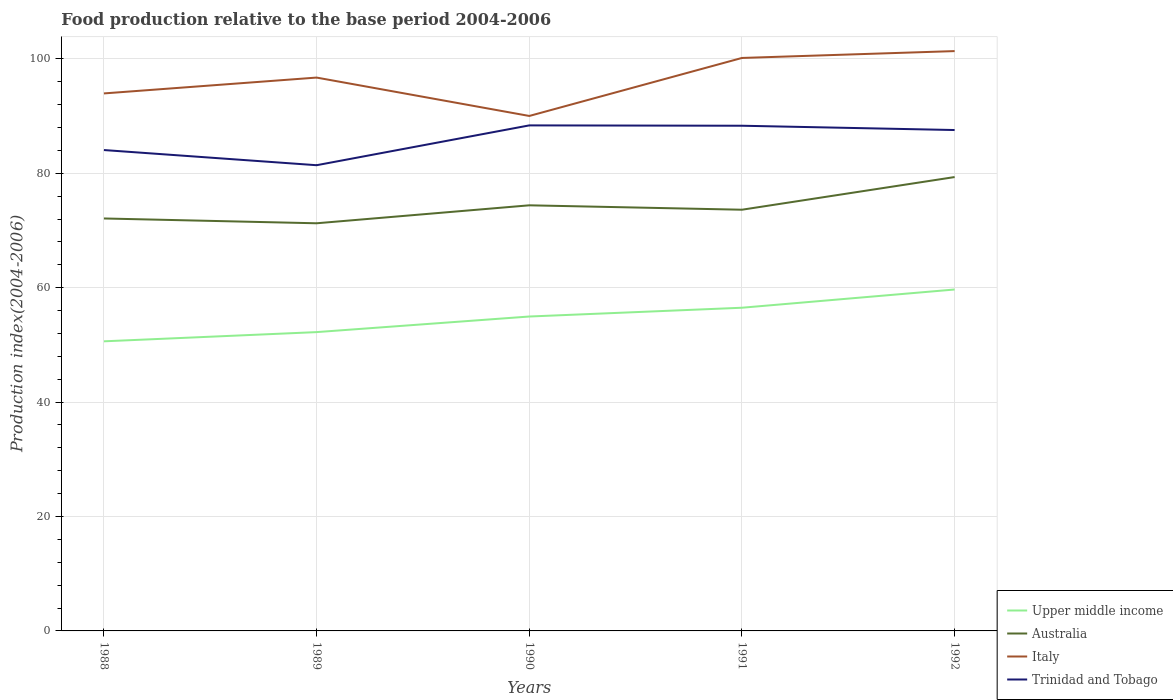How many different coloured lines are there?
Make the answer very short. 4. Does the line corresponding to Trinidad and Tobago intersect with the line corresponding to Italy?
Your answer should be compact. No. Is the number of lines equal to the number of legend labels?
Keep it short and to the point. Yes. Across all years, what is the maximum food production index in Australia?
Your response must be concise. 71.26. What is the total food production index in Trinidad and Tobago in the graph?
Keep it short and to the point. -6.15. What is the difference between the highest and the second highest food production index in Trinidad and Tobago?
Keep it short and to the point. 6.96. What is the difference between the highest and the lowest food production index in Trinidad and Tobago?
Offer a very short reply. 3. Is the food production index in Italy strictly greater than the food production index in Australia over the years?
Ensure brevity in your answer.  No. How many years are there in the graph?
Provide a succinct answer. 5. Are the values on the major ticks of Y-axis written in scientific E-notation?
Your response must be concise. No. Does the graph contain grids?
Offer a very short reply. Yes. How many legend labels are there?
Provide a succinct answer. 4. What is the title of the graph?
Your answer should be very brief. Food production relative to the base period 2004-2006. What is the label or title of the X-axis?
Your answer should be compact. Years. What is the label or title of the Y-axis?
Keep it short and to the point. Production index(2004-2006). What is the Production index(2004-2006) of Upper middle income in 1988?
Keep it short and to the point. 50.62. What is the Production index(2004-2006) in Australia in 1988?
Make the answer very short. 72.1. What is the Production index(2004-2006) in Italy in 1988?
Make the answer very short. 93.96. What is the Production index(2004-2006) of Trinidad and Tobago in 1988?
Your answer should be compact. 84.06. What is the Production index(2004-2006) in Upper middle income in 1989?
Give a very brief answer. 52.24. What is the Production index(2004-2006) of Australia in 1989?
Provide a succinct answer. 71.26. What is the Production index(2004-2006) of Italy in 1989?
Offer a very short reply. 96.73. What is the Production index(2004-2006) of Trinidad and Tobago in 1989?
Your response must be concise. 81.41. What is the Production index(2004-2006) in Upper middle income in 1990?
Ensure brevity in your answer.  54.96. What is the Production index(2004-2006) of Australia in 1990?
Provide a succinct answer. 74.4. What is the Production index(2004-2006) of Italy in 1990?
Provide a succinct answer. 90.02. What is the Production index(2004-2006) of Trinidad and Tobago in 1990?
Give a very brief answer. 88.37. What is the Production index(2004-2006) in Upper middle income in 1991?
Give a very brief answer. 56.5. What is the Production index(2004-2006) of Australia in 1991?
Provide a succinct answer. 73.63. What is the Production index(2004-2006) of Italy in 1991?
Offer a very short reply. 100.16. What is the Production index(2004-2006) in Trinidad and Tobago in 1991?
Keep it short and to the point. 88.31. What is the Production index(2004-2006) in Upper middle income in 1992?
Offer a very short reply. 59.68. What is the Production index(2004-2006) in Australia in 1992?
Ensure brevity in your answer.  79.34. What is the Production index(2004-2006) in Italy in 1992?
Give a very brief answer. 101.36. What is the Production index(2004-2006) in Trinidad and Tobago in 1992?
Provide a short and direct response. 87.56. Across all years, what is the maximum Production index(2004-2006) in Upper middle income?
Provide a short and direct response. 59.68. Across all years, what is the maximum Production index(2004-2006) of Australia?
Ensure brevity in your answer.  79.34. Across all years, what is the maximum Production index(2004-2006) of Italy?
Keep it short and to the point. 101.36. Across all years, what is the maximum Production index(2004-2006) in Trinidad and Tobago?
Offer a terse response. 88.37. Across all years, what is the minimum Production index(2004-2006) in Upper middle income?
Your answer should be compact. 50.62. Across all years, what is the minimum Production index(2004-2006) in Australia?
Give a very brief answer. 71.26. Across all years, what is the minimum Production index(2004-2006) of Italy?
Your answer should be very brief. 90.02. Across all years, what is the minimum Production index(2004-2006) in Trinidad and Tobago?
Offer a very short reply. 81.41. What is the total Production index(2004-2006) in Upper middle income in the graph?
Provide a succinct answer. 274. What is the total Production index(2004-2006) of Australia in the graph?
Make the answer very short. 370.73. What is the total Production index(2004-2006) in Italy in the graph?
Your response must be concise. 482.23. What is the total Production index(2004-2006) of Trinidad and Tobago in the graph?
Your response must be concise. 429.71. What is the difference between the Production index(2004-2006) of Upper middle income in 1988 and that in 1989?
Your answer should be very brief. -1.61. What is the difference between the Production index(2004-2006) of Australia in 1988 and that in 1989?
Provide a succinct answer. 0.84. What is the difference between the Production index(2004-2006) of Italy in 1988 and that in 1989?
Ensure brevity in your answer.  -2.77. What is the difference between the Production index(2004-2006) in Trinidad and Tobago in 1988 and that in 1989?
Your response must be concise. 2.65. What is the difference between the Production index(2004-2006) of Upper middle income in 1988 and that in 1990?
Your response must be concise. -4.34. What is the difference between the Production index(2004-2006) in Australia in 1988 and that in 1990?
Offer a terse response. -2.3. What is the difference between the Production index(2004-2006) in Italy in 1988 and that in 1990?
Give a very brief answer. 3.94. What is the difference between the Production index(2004-2006) in Trinidad and Tobago in 1988 and that in 1990?
Keep it short and to the point. -4.31. What is the difference between the Production index(2004-2006) in Upper middle income in 1988 and that in 1991?
Your response must be concise. -5.87. What is the difference between the Production index(2004-2006) in Australia in 1988 and that in 1991?
Your response must be concise. -1.53. What is the difference between the Production index(2004-2006) in Italy in 1988 and that in 1991?
Keep it short and to the point. -6.2. What is the difference between the Production index(2004-2006) in Trinidad and Tobago in 1988 and that in 1991?
Your answer should be compact. -4.25. What is the difference between the Production index(2004-2006) in Upper middle income in 1988 and that in 1992?
Offer a terse response. -9.06. What is the difference between the Production index(2004-2006) in Australia in 1988 and that in 1992?
Your answer should be very brief. -7.24. What is the difference between the Production index(2004-2006) in Italy in 1988 and that in 1992?
Ensure brevity in your answer.  -7.4. What is the difference between the Production index(2004-2006) in Trinidad and Tobago in 1988 and that in 1992?
Provide a succinct answer. -3.5. What is the difference between the Production index(2004-2006) of Upper middle income in 1989 and that in 1990?
Your answer should be very brief. -2.73. What is the difference between the Production index(2004-2006) of Australia in 1989 and that in 1990?
Your answer should be compact. -3.14. What is the difference between the Production index(2004-2006) of Italy in 1989 and that in 1990?
Provide a succinct answer. 6.71. What is the difference between the Production index(2004-2006) of Trinidad and Tobago in 1989 and that in 1990?
Your answer should be very brief. -6.96. What is the difference between the Production index(2004-2006) in Upper middle income in 1989 and that in 1991?
Give a very brief answer. -4.26. What is the difference between the Production index(2004-2006) of Australia in 1989 and that in 1991?
Offer a terse response. -2.37. What is the difference between the Production index(2004-2006) in Italy in 1989 and that in 1991?
Keep it short and to the point. -3.43. What is the difference between the Production index(2004-2006) of Trinidad and Tobago in 1989 and that in 1991?
Provide a succinct answer. -6.9. What is the difference between the Production index(2004-2006) in Upper middle income in 1989 and that in 1992?
Offer a terse response. -7.45. What is the difference between the Production index(2004-2006) of Australia in 1989 and that in 1992?
Ensure brevity in your answer.  -8.08. What is the difference between the Production index(2004-2006) in Italy in 1989 and that in 1992?
Make the answer very short. -4.63. What is the difference between the Production index(2004-2006) in Trinidad and Tobago in 1989 and that in 1992?
Provide a short and direct response. -6.15. What is the difference between the Production index(2004-2006) in Upper middle income in 1990 and that in 1991?
Make the answer very short. -1.54. What is the difference between the Production index(2004-2006) of Australia in 1990 and that in 1991?
Give a very brief answer. 0.77. What is the difference between the Production index(2004-2006) of Italy in 1990 and that in 1991?
Offer a very short reply. -10.14. What is the difference between the Production index(2004-2006) of Trinidad and Tobago in 1990 and that in 1991?
Keep it short and to the point. 0.06. What is the difference between the Production index(2004-2006) in Upper middle income in 1990 and that in 1992?
Your answer should be compact. -4.72. What is the difference between the Production index(2004-2006) in Australia in 1990 and that in 1992?
Your answer should be compact. -4.94. What is the difference between the Production index(2004-2006) of Italy in 1990 and that in 1992?
Your response must be concise. -11.34. What is the difference between the Production index(2004-2006) in Trinidad and Tobago in 1990 and that in 1992?
Your response must be concise. 0.81. What is the difference between the Production index(2004-2006) in Upper middle income in 1991 and that in 1992?
Offer a terse response. -3.19. What is the difference between the Production index(2004-2006) in Australia in 1991 and that in 1992?
Give a very brief answer. -5.71. What is the difference between the Production index(2004-2006) in Trinidad and Tobago in 1991 and that in 1992?
Make the answer very short. 0.75. What is the difference between the Production index(2004-2006) of Upper middle income in 1988 and the Production index(2004-2006) of Australia in 1989?
Make the answer very short. -20.64. What is the difference between the Production index(2004-2006) of Upper middle income in 1988 and the Production index(2004-2006) of Italy in 1989?
Your answer should be very brief. -46.11. What is the difference between the Production index(2004-2006) of Upper middle income in 1988 and the Production index(2004-2006) of Trinidad and Tobago in 1989?
Your response must be concise. -30.79. What is the difference between the Production index(2004-2006) in Australia in 1988 and the Production index(2004-2006) in Italy in 1989?
Offer a very short reply. -24.63. What is the difference between the Production index(2004-2006) in Australia in 1988 and the Production index(2004-2006) in Trinidad and Tobago in 1989?
Give a very brief answer. -9.31. What is the difference between the Production index(2004-2006) in Italy in 1988 and the Production index(2004-2006) in Trinidad and Tobago in 1989?
Provide a succinct answer. 12.55. What is the difference between the Production index(2004-2006) of Upper middle income in 1988 and the Production index(2004-2006) of Australia in 1990?
Your answer should be compact. -23.78. What is the difference between the Production index(2004-2006) of Upper middle income in 1988 and the Production index(2004-2006) of Italy in 1990?
Ensure brevity in your answer.  -39.4. What is the difference between the Production index(2004-2006) in Upper middle income in 1988 and the Production index(2004-2006) in Trinidad and Tobago in 1990?
Your response must be concise. -37.75. What is the difference between the Production index(2004-2006) in Australia in 1988 and the Production index(2004-2006) in Italy in 1990?
Keep it short and to the point. -17.92. What is the difference between the Production index(2004-2006) in Australia in 1988 and the Production index(2004-2006) in Trinidad and Tobago in 1990?
Keep it short and to the point. -16.27. What is the difference between the Production index(2004-2006) in Italy in 1988 and the Production index(2004-2006) in Trinidad and Tobago in 1990?
Your response must be concise. 5.59. What is the difference between the Production index(2004-2006) of Upper middle income in 1988 and the Production index(2004-2006) of Australia in 1991?
Keep it short and to the point. -23.01. What is the difference between the Production index(2004-2006) in Upper middle income in 1988 and the Production index(2004-2006) in Italy in 1991?
Your answer should be very brief. -49.54. What is the difference between the Production index(2004-2006) in Upper middle income in 1988 and the Production index(2004-2006) in Trinidad and Tobago in 1991?
Offer a terse response. -37.69. What is the difference between the Production index(2004-2006) in Australia in 1988 and the Production index(2004-2006) in Italy in 1991?
Your answer should be compact. -28.06. What is the difference between the Production index(2004-2006) of Australia in 1988 and the Production index(2004-2006) of Trinidad and Tobago in 1991?
Your answer should be very brief. -16.21. What is the difference between the Production index(2004-2006) in Italy in 1988 and the Production index(2004-2006) in Trinidad and Tobago in 1991?
Offer a very short reply. 5.65. What is the difference between the Production index(2004-2006) in Upper middle income in 1988 and the Production index(2004-2006) in Australia in 1992?
Your answer should be compact. -28.72. What is the difference between the Production index(2004-2006) in Upper middle income in 1988 and the Production index(2004-2006) in Italy in 1992?
Ensure brevity in your answer.  -50.74. What is the difference between the Production index(2004-2006) of Upper middle income in 1988 and the Production index(2004-2006) of Trinidad and Tobago in 1992?
Provide a short and direct response. -36.94. What is the difference between the Production index(2004-2006) in Australia in 1988 and the Production index(2004-2006) in Italy in 1992?
Ensure brevity in your answer.  -29.26. What is the difference between the Production index(2004-2006) in Australia in 1988 and the Production index(2004-2006) in Trinidad and Tobago in 1992?
Offer a terse response. -15.46. What is the difference between the Production index(2004-2006) of Italy in 1988 and the Production index(2004-2006) of Trinidad and Tobago in 1992?
Offer a terse response. 6.4. What is the difference between the Production index(2004-2006) of Upper middle income in 1989 and the Production index(2004-2006) of Australia in 1990?
Your answer should be compact. -22.16. What is the difference between the Production index(2004-2006) of Upper middle income in 1989 and the Production index(2004-2006) of Italy in 1990?
Make the answer very short. -37.78. What is the difference between the Production index(2004-2006) in Upper middle income in 1989 and the Production index(2004-2006) in Trinidad and Tobago in 1990?
Your answer should be very brief. -36.13. What is the difference between the Production index(2004-2006) in Australia in 1989 and the Production index(2004-2006) in Italy in 1990?
Your answer should be very brief. -18.76. What is the difference between the Production index(2004-2006) of Australia in 1989 and the Production index(2004-2006) of Trinidad and Tobago in 1990?
Ensure brevity in your answer.  -17.11. What is the difference between the Production index(2004-2006) of Italy in 1989 and the Production index(2004-2006) of Trinidad and Tobago in 1990?
Make the answer very short. 8.36. What is the difference between the Production index(2004-2006) of Upper middle income in 1989 and the Production index(2004-2006) of Australia in 1991?
Offer a very short reply. -21.39. What is the difference between the Production index(2004-2006) of Upper middle income in 1989 and the Production index(2004-2006) of Italy in 1991?
Provide a short and direct response. -47.92. What is the difference between the Production index(2004-2006) of Upper middle income in 1989 and the Production index(2004-2006) of Trinidad and Tobago in 1991?
Keep it short and to the point. -36.07. What is the difference between the Production index(2004-2006) of Australia in 1989 and the Production index(2004-2006) of Italy in 1991?
Provide a short and direct response. -28.9. What is the difference between the Production index(2004-2006) in Australia in 1989 and the Production index(2004-2006) in Trinidad and Tobago in 1991?
Your answer should be very brief. -17.05. What is the difference between the Production index(2004-2006) in Italy in 1989 and the Production index(2004-2006) in Trinidad and Tobago in 1991?
Offer a very short reply. 8.42. What is the difference between the Production index(2004-2006) in Upper middle income in 1989 and the Production index(2004-2006) in Australia in 1992?
Your answer should be very brief. -27.1. What is the difference between the Production index(2004-2006) in Upper middle income in 1989 and the Production index(2004-2006) in Italy in 1992?
Ensure brevity in your answer.  -49.12. What is the difference between the Production index(2004-2006) in Upper middle income in 1989 and the Production index(2004-2006) in Trinidad and Tobago in 1992?
Your answer should be compact. -35.32. What is the difference between the Production index(2004-2006) of Australia in 1989 and the Production index(2004-2006) of Italy in 1992?
Provide a short and direct response. -30.1. What is the difference between the Production index(2004-2006) in Australia in 1989 and the Production index(2004-2006) in Trinidad and Tobago in 1992?
Make the answer very short. -16.3. What is the difference between the Production index(2004-2006) in Italy in 1989 and the Production index(2004-2006) in Trinidad and Tobago in 1992?
Provide a succinct answer. 9.17. What is the difference between the Production index(2004-2006) in Upper middle income in 1990 and the Production index(2004-2006) in Australia in 1991?
Provide a succinct answer. -18.67. What is the difference between the Production index(2004-2006) of Upper middle income in 1990 and the Production index(2004-2006) of Italy in 1991?
Ensure brevity in your answer.  -45.2. What is the difference between the Production index(2004-2006) of Upper middle income in 1990 and the Production index(2004-2006) of Trinidad and Tobago in 1991?
Keep it short and to the point. -33.35. What is the difference between the Production index(2004-2006) of Australia in 1990 and the Production index(2004-2006) of Italy in 1991?
Keep it short and to the point. -25.76. What is the difference between the Production index(2004-2006) of Australia in 1990 and the Production index(2004-2006) of Trinidad and Tobago in 1991?
Keep it short and to the point. -13.91. What is the difference between the Production index(2004-2006) of Italy in 1990 and the Production index(2004-2006) of Trinidad and Tobago in 1991?
Provide a succinct answer. 1.71. What is the difference between the Production index(2004-2006) in Upper middle income in 1990 and the Production index(2004-2006) in Australia in 1992?
Provide a succinct answer. -24.38. What is the difference between the Production index(2004-2006) in Upper middle income in 1990 and the Production index(2004-2006) in Italy in 1992?
Make the answer very short. -46.4. What is the difference between the Production index(2004-2006) of Upper middle income in 1990 and the Production index(2004-2006) of Trinidad and Tobago in 1992?
Offer a very short reply. -32.6. What is the difference between the Production index(2004-2006) in Australia in 1990 and the Production index(2004-2006) in Italy in 1992?
Your answer should be compact. -26.96. What is the difference between the Production index(2004-2006) in Australia in 1990 and the Production index(2004-2006) in Trinidad and Tobago in 1992?
Ensure brevity in your answer.  -13.16. What is the difference between the Production index(2004-2006) in Italy in 1990 and the Production index(2004-2006) in Trinidad and Tobago in 1992?
Make the answer very short. 2.46. What is the difference between the Production index(2004-2006) in Upper middle income in 1991 and the Production index(2004-2006) in Australia in 1992?
Offer a very short reply. -22.84. What is the difference between the Production index(2004-2006) of Upper middle income in 1991 and the Production index(2004-2006) of Italy in 1992?
Keep it short and to the point. -44.86. What is the difference between the Production index(2004-2006) of Upper middle income in 1991 and the Production index(2004-2006) of Trinidad and Tobago in 1992?
Make the answer very short. -31.06. What is the difference between the Production index(2004-2006) in Australia in 1991 and the Production index(2004-2006) in Italy in 1992?
Offer a terse response. -27.73. What is the difference between the Production index(2004-2006) of Australia in 1991 and the Production index(2004-2006) of Trinidad and Tobago in 1992?
Provide a short and direct response. -13.93. What is the average Production index(2004-2006) in Upper middle income per year?
Your response must be concise. 54.8. What is the average Production index(2004-2006) of Australia per year?
Ensure brevity in your answer.  74.15. What is the average Production index(2004-2006) of Italy per year?
Provide a succinct answer. 96.45. What is the average Production index(2004-2006) of Trinidad and Tobago per year?
Give a very brief answer. 85.94. In the year 1988, what is the difference between the Production index(2004-2006) in Upper middle income and Production index(2004-2006) in Australia?
Offer a terse response. -21.48. In the year 1988, what is the difference between the Production index(2004-2006) of Upper middle income and Production index(2004-2006) of Italy?
Offer a terse response. -43.34. In the year 1988, what is the difference between the Production index(2004-2006) of Upper middle income and Production index(2004-2006) of Trinidad and Tobago?
Your response must be concise. -33.44. In the year 1988, what is the difference between the Production index(2004-2006) of Australia and Production index(2004-2006) of Italy?
Offer a very short reply. -21.86. In the year 1988, what is the difference between the Production index(2004-2006) of Australia and Production index(2004-2006) of Trinidad and Tobago?
Your response must be concise. -11.96. In the year 1988, what is the difference between the Production index(2004-2006) in Italy and Production index(2004-2006) in Trinidad and Tobago?
Your answer should be very brief. 9.9. In the year 1989, what is the difference between the Production index(2004-2006) of Upper middle income and Production index(2004-2006) of Australia?
Make the answer very short. -19.02. In the year 1989, what is the difference between the Production index(2004-2006) of Upper middle income and Production index(2004-2006) of Italy?
Your answer should be compact. -44.49. In the year 1989, what is the difference between the Production index(2004-2006) of Upper middle income and Production index(2004-2006) of Trinidad and Tobago?
Your answer should be compact. -29.17. In the year 1989, what is the difference between the Production index(2004-2006) in Australia and Production index(2004-2006) in Italy?
Provide a succinct answer. -25.47. In the year 1989, what is the difference between the Production index(2004-2006) in Australia and Production index(2004-2006) in Trinidad and Tobago?
Ensure brevity in your answer.  -10.15. In the year 1989, what is the difference between the Production index(2004-2006) of Italy and Production index(2004-2006) of Trinidad and Tobago?
Keep it short and to the point. 15.32. In the year 1990, what is the difference between the Production index(2004-2006) of Upper middle income and Production index(2004-2006) of Australia?
Provide a short and direct response. -19.44. In the year 1990, what is the difference between the Production index(2004-2006) of Upper middle income and Production index(2004-2006) of Italy?
Offer a very short reply. -35.06. In the year 1990, what is the difference between the Production index(2004-2006) in Upper middle income and Production index(2004-2006) in Trinidad and Tobago?
Provide a succinct answer. -33.41. In the year 1990, what is the difference between the Production index(2004-2006) of Australia and Production index(2004-2006) of Italy?
Your response must be concise. -15.62. In the year 1990, what is the difference between the Production index(2004-2006) of Australia and Production index(2004-2006) of Trinidad and Tobago?
Make the answer very short. -13.97. In the year 1990, what is the difference between the Production index(2004-2006) of Italy and Production index(2004-2006) of Trinidad and Tobago?
Your answer should be very brief. 1.65. In the year 1991, what is the difference between the Production index(2004-2006) of Upper middle income and Production index(2004-2006) of Australia?
Offer a very short reply. -17.13. In the year 1991, what is the difference between the Production index(2004-2006) of Upper middle income and Production index(2004-2006) of Italy?
Your response must be concise. -43.66. In the year 1991, what is the difference between the Production index(2004-2006) in Upper middle income and Production index(2004-2006) in Trinidad and Tobago?
Offer a terse response. -31.81. In the year 1991, what is the difference between the Production index(2004-2006) of Australia and Production index(2004-2006) of Italy?
Your response must be concise. -26.53. In the year 1991, what is the difference between the Production index(2004-2006) of Australia and Production index(2004-2006) of Trinidad and Tobago?
Offer a very short reply. -14.68. In the year 1991, what is the difference between the Production index(2004-2006) in Italy and Production index(2004-2006) in Trinidad and Tobago?
Make the answer very short. 11.85. In the year 1992, what is the difference between the Production index(2004-2006) of Upper middle income and Production index(2004-2006) of Australia?
Your response must be concise. -19.66. In the year 1992, what is the difference between the Production index(2004-2006) of Upper middle income and Production index(2004-2006) of Italy?
Give a very brief answer. -41.68. In the year 1992, what is the difference between the Production index(2004-2006) of Upper middle income and Production index(2004-2006) of Trinidad and Tobago?
Offer a terse response. -27.88. In the year 1992, what is the difference between the Production index(2004-2006) of Australia and Production index(2004-2006) of Italy?
Offer a terse response. -22.02. In the year 1992, what is the difference between the Production index(2004-2006) in Australia and Production index(2004-2006) in Trinidad and Tobago?
Give a very brief answer. -8.22. In the year 1992, what is the difference between the Production index(2004-2006) in Italy and Production index(2004-2006) in Trinidad and Tobago?
Make the answer very short. 13.8. What is the ratio of the Production index(2004-2006) of Upper middle income in 1988 to that in 1989?
Your response must be concise. 0.97. What is the ratio of the Production index(2004-2006) in Australia in 1988 to that in 1989?
Offer a very short reply. 1.01. What is the ratio of the Production index(2004-2006) in Italy in 1988 to that in 1989?
Offer a very short reply. 0.97. What is the ratio of the Production index(2004-2006) of Trinidad and Tobago in 1988 to that in 1989?
Keep it short and to the point. 1.03. What is the ratio of the Production index(2004-2006) of Upper middle income in 1988 to that in 1990?
Provide a succinct answer. 0.92. What is the ratio of the Production index(2004-2006) of Australia in 1988 to that in 1990?
Your response must be concise. 0.97. What is the ratio of the Production index(2004-2006) of Italy in 1988 to that in 1990?
Provide a succinct answer. 1.04. What is the ratio of the Production index(2004-2006) in Trinidad and Tobago in 1988 to that in 1990?
Offer a very short reply. 0.95. What is the ratio of the Production index(2004-2006) in Upper middle income in 1988 to that in 1991?
Your answer should be compact. 0.9. What is the ratio of the Production index(2004-2006) of Australia in 1988 to that in 1991?
Your answer should be compact. 0.98. What is the ratio of the Production index(2004-2006) in Italy in 1988 to that in 1991?
Make the answer very short. 0.94. What is the ratio of the Production index(2004-2006) in Trinidad and Tobago in 1988 to that in 1991?
Keep it short and to the point. 0.95. What is the ratio of the Production index(2004-2006) of Upper middle income in 1988 to that in 1992?
Provide a succinct answer. 0.85. What is the ratio of the Production index(2004-2006) of Australia in 1988 to that in 1992?
Your answer should be very brief. 0.91. What is the ratio of the Production index(2004-2006) in Italy in 1988 to that in 1992?
Keep it short and to the point. 0.93. What is the ratio of the Production index(2004-2006) of Trinidad and Tobago in 1988 to that in 1992?
Offer a very short reply. 0.96. What is the ratio of the Production index(2004-2006) of Upper middle income in 1989 to that in 1990?
Your answer should be compact. 0.95. What is the ratio of the Production index(2004-2006) of Australia in 1989 to that in 1990?
Your response must be concise. 0.96. What is the ratio of the Production index(2004-2006) in Italy in 1989 to that in 1990?
Your answer should be very brief. 1.07. What is the ratio of the Production index(2004-2006) in Trinidad and Tobago in 1989 to that in 1990?
Offer a very short reply. 0.92. What is the ratio of the Production index(2004-2006) of Upper middle income in 1989 to that in 1991?
Give a very brief answer. 0.92. What is the ratio of the Production index(2004-2006) in Australia in 1989 to that in 1991?
Your answer should be very brief. 0.97. What is the ratio of the Production index(2004-2006) in Italy in 1989 to that in 1991?
Your response must be concise. 0.97. What is the ratio of the Production index(2004-2006) in Trinidad and Tobago in 1989 to that in 1991?
Your response must be concise. 0.92. What is the ratio of the Production index(2004-2006) in Upper middle income in 1989 to that in 1992?
Your answer should be very brief. 0.88. What is the ratio of the Production index(2004-2006) in Australia in 1989 to that in 1992?
Ensure brevity in your answer.  0.9. What is the ratio of the Production index(2004-2006) of Italy in 1989 to that in 1992?
Offer a very short reply. 0.95. What is the ratio of the Production index(2004-2006) of Trinidad and Tobago in 1989 to that in 1992?
Your answer should be very brief. 0.93. What is the ratio of the Production index(2004-2006) in Upper middle income in 1990 to that in 1991?
Ensure brevity in your answer.  0.97. What is the ratio of the Production index(2004-2006) in Australia in 1990 to that in 1991?
Offer a very short reply. 1.01. What is the ratio of the Production index(2004-2006) in Italy in 1990 to that in 1991?
Offer a very short reply. 0.9. What is the ratio of the Production index(2004-2006) of Trinidad and Tobago in 1990 to that in 1991?
Provide a succinct answer. 1. What is the ratio of the Production index(2004-2006) in Upper middle income in 1990 to that in 1992?
Make the answer very short. 0.92. What is the ratio of the Production index(2004-2006) of Australia in 1990 to that in 1992?
Offer a very short reply. 0.94. What is the ratio of the Production index(2004-2006) in Italy in 1990 to that in 1992?
Offer a terse response. 0.89. What is the ratio of the Production index(2004-2006) of Trinidad and Tobago in 1990 to that in 1992?
Ensure brevity in your answer.  1.01. What is the ratio of the Production index(2004-2006) of Upper middle income in 1991 to that in 1992?
Keep it short and to the point. 0.95. What is the ratio of the Production index(2004-2006) of Australia in 1991 to that in 1992?
Your answer should be compact. 0.93. What is the ratio of the Production index(2004-2006) in Trinidad and Tobago in 1991 to that in 1992?
Make the answer very short. 1.01. What is the difference between the highest and the second highest Production index(2004-2006) of Upper middle income?
Your answer should be compact. 3.19. What is the difference between the highest and the second highest Production index(2004-2006) of Australia?
Keep it short and to the point. 4.94. What is the difference between the highest and the second highest Production index(2004-2006) of Italy?
Your answer should be compact. 1.2. What is the difference between the highest and the second highest Production index(2004-2006) in Trinidad and Tobago?
Offer a very short reply. 0.06. What is the difference between the highest and the lowest Production index(2004-2006) of Upper middle income?
Ensure brevity in your answer.  9.06. What is the difference between the highest and the lowest Production index(2004-2006) of Australia?
Provide a succinct answer. 8.08. What is the difference between the highest and the lowest Production index(2004-2006) in Italy?
Provide a succinct answer. 11.34. What is the difference between the highest and the lowest Production index(2004-2006) of Trinidad and Tobago?
Your answer should be very brief. 6.96. 